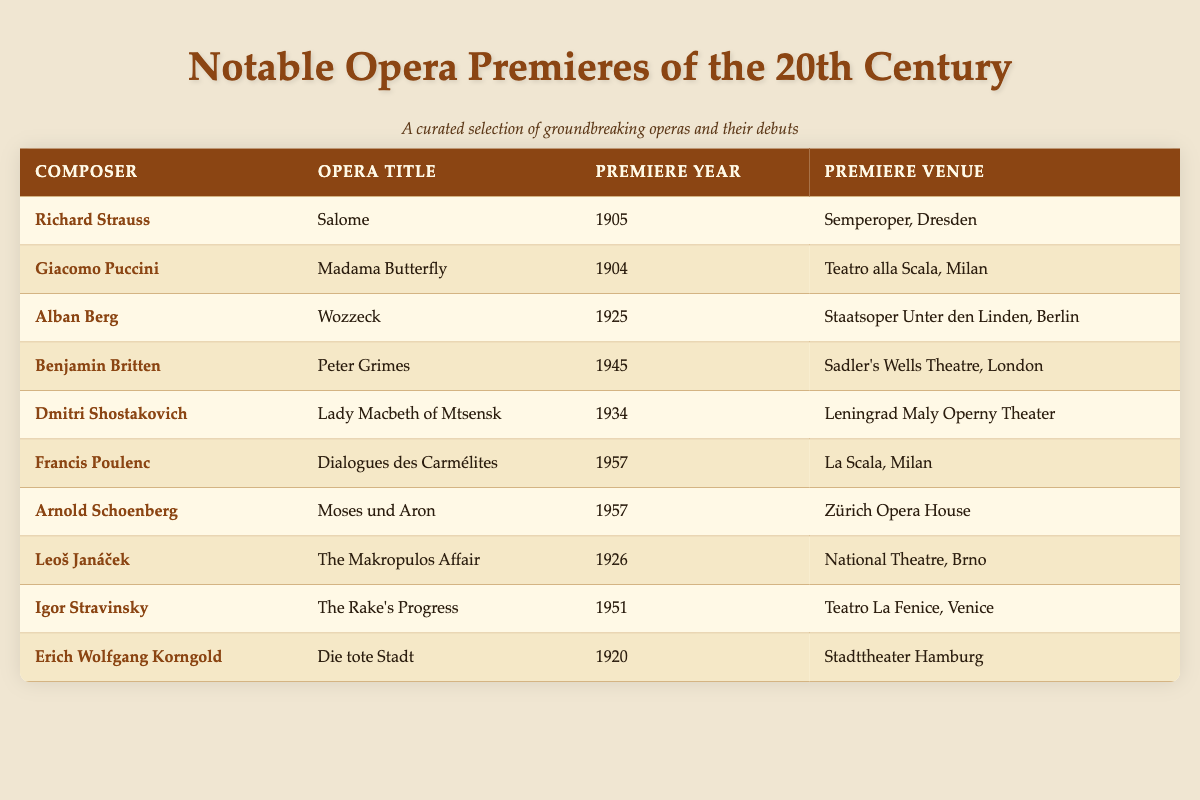What is the premiere year of "Madama Butterfly"? The table lists "Madama Butterfly" by Giacomo Puccini with a premiere year of "1904".
Answer: 1904 Who premiered the opera "Wozzeck"? "Wozzeck" is listed with the composer Alban Berg, indicating that he was the one who premiered this opera.
Answer: Alban Berg How many operas premiered in the 1920s? The table lists three operas that premiered in the 1920s: "Wozzeck" (1925), "The Makropulos Affair" (1926), and "Die tote Stadt" (1920). Therefore, the total count is 3.
Answer: 3 Did any operas premier in 1957? The table shows two operas that premiered in 1957: "Dialogues des Carmélites" by Francis Poulenc and "Moses und Aron" by Arnold Schoenberg. Thus, the answer is yes.
Answer: Yes Which composer had an opera premiere in the venue "Teatro alla Scala, Milan"? The table identifies that "Madama Butterfly" by Giacomo Puccini and "Dialogues des Carmélites" by Francis Poulenc both premiered at "Teatro alla Scala, Milan". Thus, two composers (Puccini and Poulenc) had works premiered there.
Answer: Giacomo Puccini and Francis Poulenc What is the difference between the premiere years of "Salome" and "Die tote Stadt"? "Salome" premiered in 1905 and "Die tote Stadt" premiered in 1920. The difference in years is 1920 - 1905 = 15 years.
Answer: 15 years List the names of the composers who premiered operas in the 1950s. The table shows that both Francis Poulenc (with "Dialogues des Carmélites") and Arnold Schoenberg (with "Moses und Aron") had operas premiere in 1957; thus, those two composers are the answer.
Answer: Francis Poulenc and Arnold Schoenberg How many of the listed operas had their premieres in locations outside of Vienna? The table shows that all listed operas premiered in locations outside of Vienna, indicating that there are 10 operas that fit this criterion.
Answer: 10 Which opera had the earliest premiere in the table? Upon examining the table, "Madama Butterfly" premiered in 1904, making it the earliest premiere in the list.
Answer: Madama Butterfly 